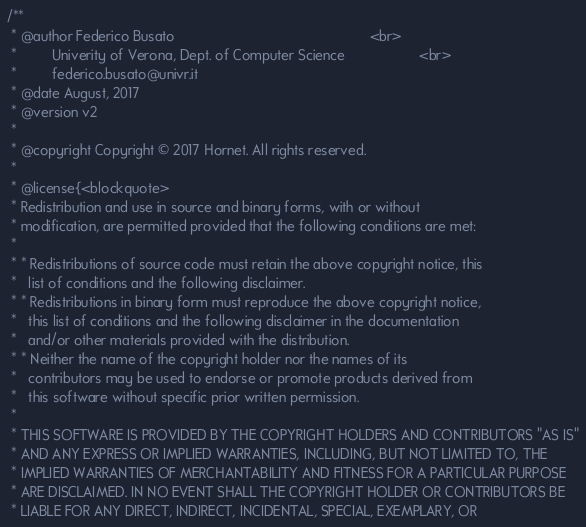<code> <loc_0><loc_0><loc_500><loc_500><_Cuda_>/**
 * @author Federico Busato                                                  <br>
 *         Univerity of Verona, Dept. of Computer Science                   <br>
 *         federico.busato@univr.it
 * @date August, 2017
 * @version v2
 *
 * @copyright Copyright © 2017 Hornet. All rights reserved.
 *
 * @license{<blockquote>
 * Redistribution and use in source and binary forms, with or without
 * modification, are permitted provided that the following conditions are met:
 *
 * * Redistributions of source code must retain the above copyright notice, this
 *   list of conditions and the following disclaimer.
 * * Redistributions in binary form must reproduce the above copyright notice,
 *   this list of conditions and the following disclaimer in the documentation
 *   and/or other materials provided with the distribution.
 * * Neither the name of the copyright holder nor the names of its
 *   contributors may be used to endorse or promote products derived from
 *   this software without specific prior written permission.
 *
 * THIS SOFTWARE IS PROVIDED BY THE COPYRIGHT HOLDERS AND CONTRIBUTORS "AS IS"
 * AND ANY EXPRESS OR IMPLIED WARRANTIES, INCLUDING, BUT NOT LIMITED TO, THE
 * IMPLIED WARRANTIES OF MERCHANTABILITY AND FITNESS FOR A PARTICULAR PURPOSE
 * ARE DISCLAIMED. IN NO EVENT SHALL THE COPYRIGHT HOLDER OR CONTRIBUTORS BE
 * LIABLE FOR ANY DIRECT, INDIRECT, INCIDENTAL, SPECIAL, EXEMPLARY, OR</code> 